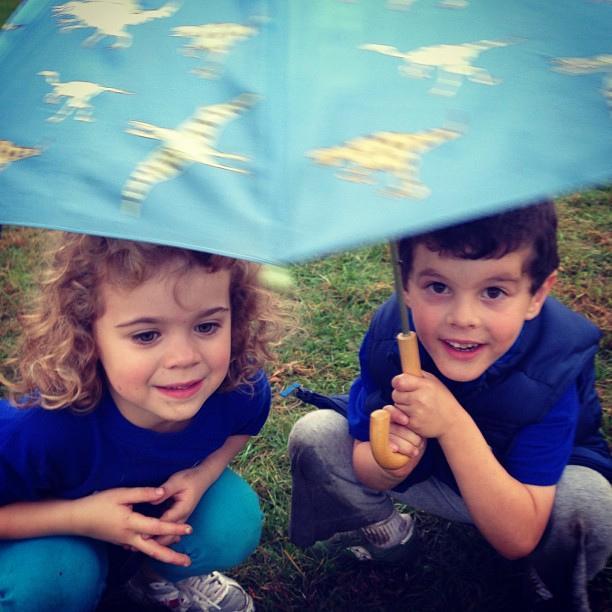How many people are there?
Give a very brief answer. 2. 